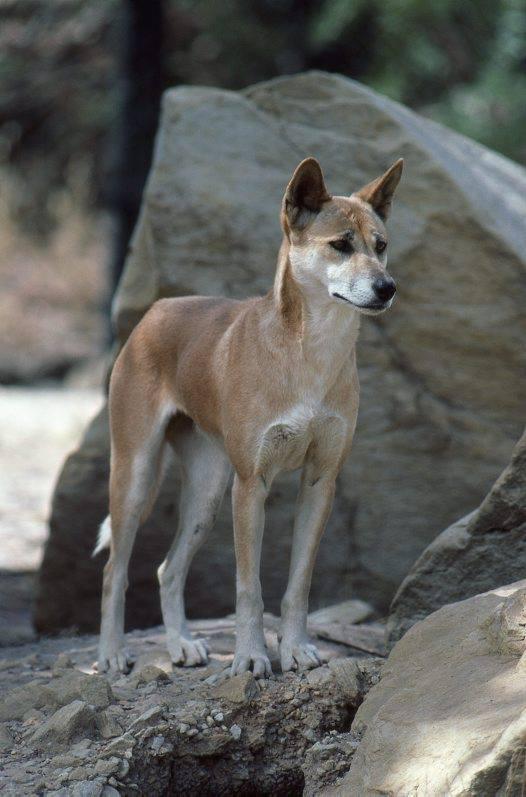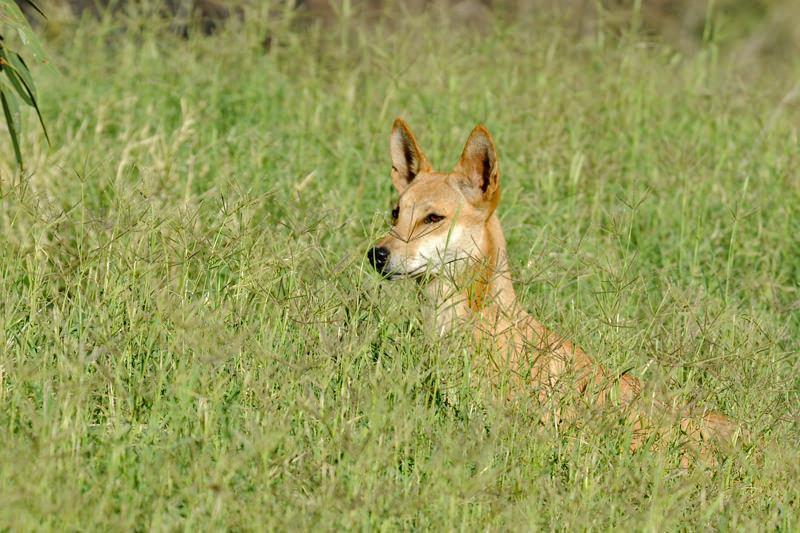The first image is the image on the left, the second image is the image on the right. For the images shown, is this caption "There are two dogs in total." true? Answer yes or no. Yes. 